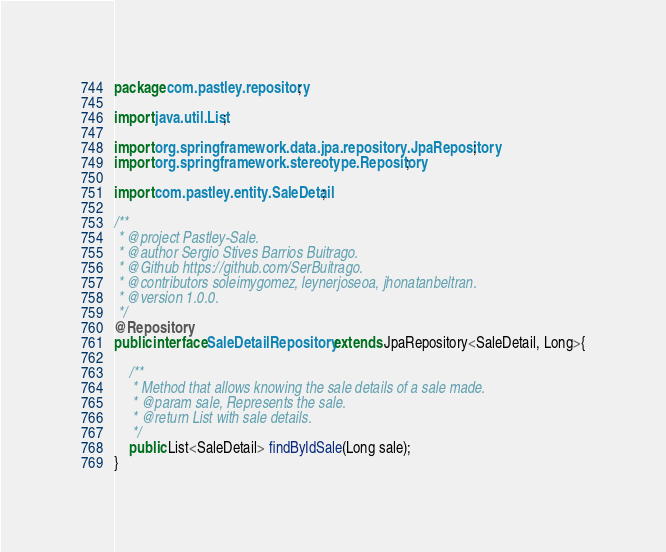<code> <loc_0><loc_0><loc_500><loc_500><_Java_>package com.pastley.repository;

import java.util.List;

import org.springframework.data.jpa.repository.JpaRepository;
import org.springframework.stereotype.Repository;

import com.pastley.entity.SaleDetail;

/**
 * @project Pastley-Sale.
 * @author Sergio Stives Barrios Buitrago.
 * @Github https://github.com/SerBuitrago.
 * @contributors soleimygomez, leynerjoseoa, jhonatanbeltran.
 * @version 1.0.0.
 */
@Repository
public interface SaleDetailRepository extends JpaRepository<SaleDetail, Long>{
	
	/**
	 * Method that allows knowing the sale details of a sale made.
	 * @param sale, Represents the sale.
	 * @return List with sale details.
	 */
	public List<SaleDetail> findByIdSale(Long sale);
}
</code> 